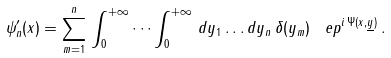Convert formula to latex. <formula><loc_0><loc_0><loc_500><loc_500>\psi _ { n } ^ { \prime } ( x ) = \sum _ { m = 1 } ^ { n } \, \int _ { 0 } ^ { + \infty } \, \dots \int _ { 0 } ^ { + \infty } \, d y _ { 1 } \dots d y _ { n } \, \delta ( y _ { m } ) \, \ e p ^ { i \, \Psi ( x , \underline { y } ) } \, .</formula> 